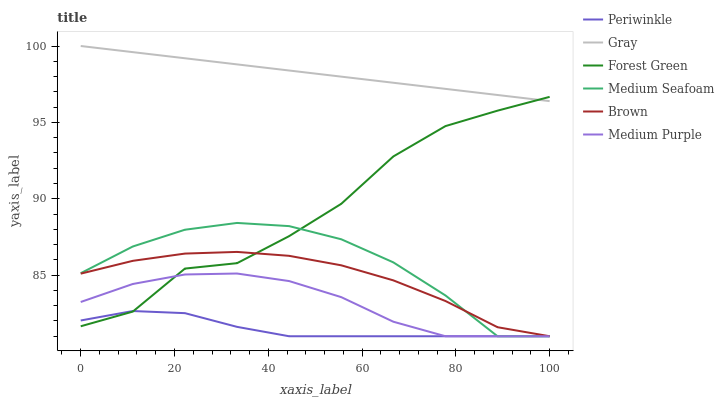Does Periwinkle have the minimum area under the curve?
Answer yes or no. Yes. Does Gray have the maximum area under the curve?
Answer yes or no. Yes. Does Brown have the minimum area under the curve?
Answer yes or no. No. Does Brown have the maximum area under the curve?
Answer yes or no. No. Is Gray the smoothest?
Answer yes or no. Yes. Is Forest Green the roughest?
Answer yes or no. Yes. Is Brown the smoothest?
Answer yes or no. No. Is Brown the roughest?
Answer yes or no. No. Does Brown have the lowest value?
Answer yes or no. Yes. Does Forest Green have the lowest value?
Answer yes or no. No. Does Gray have the highest value?
Answer yes or no. Yes. Does Brown have the highest value?
Answer yes or no. No. Is Periwinkle less than Gray?
Answer yes or no. Yes. Is Gray greater than Medium Seafoam?
Answer yes or no. Yes. Does Forest Green intersect Medium Purple?
Answer yes or no. Yes. Is Forest Green less than Medium Purple?
Answer yes or no. No. Is Forest Green greater than Medium Purple?
Answer yes or no. No. Does Periwinkle intersect Gray?
Answer yes or no. No. 